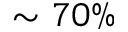Convert formula to latex. <formula><loc_0><loc_0><loc_500><loc_500>\sim 7 0 \%</formula> 